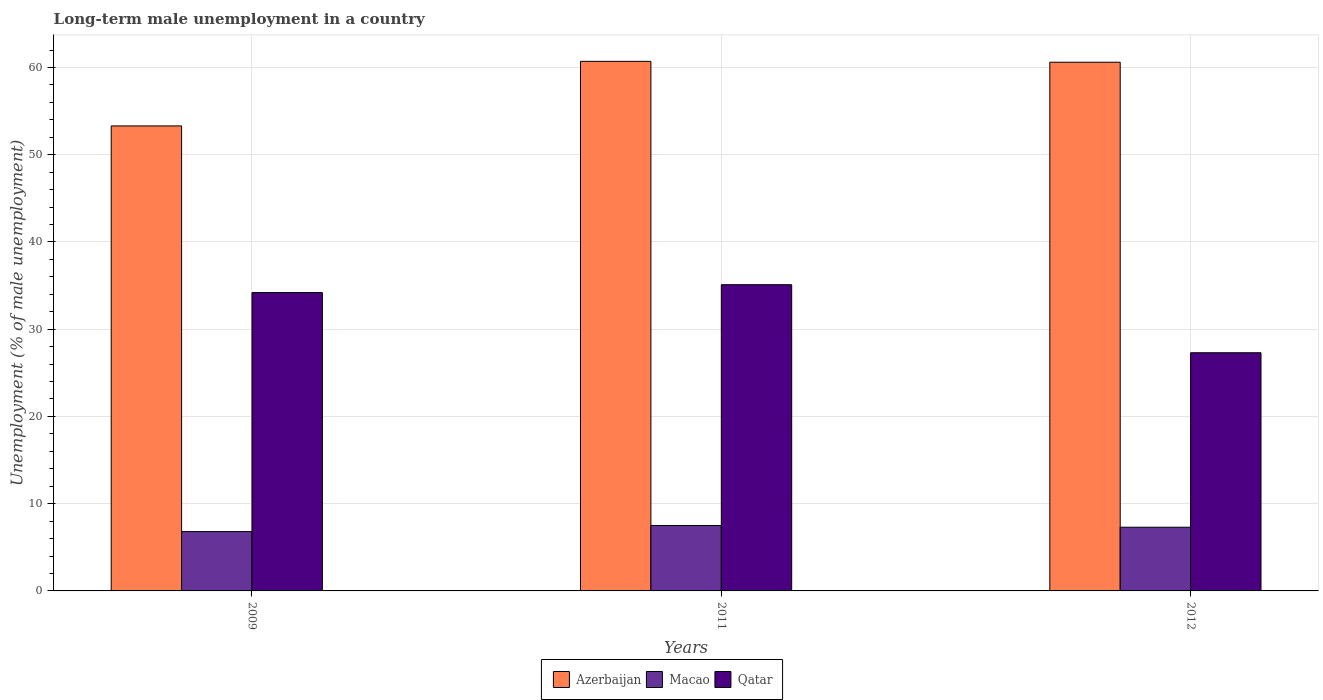How many different coloured bars are there?
Your answer should be compact. 3. How many groups of bars are there?
Give a very brief answer. 3. Are the number of bars per tick equal to the number of legend labels?
Make the answer very short. Yes. Are the number of bars on each tick of the X-axis equal?
Provide a succinct answer. Yes. What is the label of the 1st group of bars from the left?
Your answer should be compact. 2009. In how many cases, is the number of bars for a given year not equal to the number of legend labels?
Provide a short and direct response. 0. What is the percentage of long-term unemployed male population in Macao in 2009?
Provide a short and direct response. 6.8. Across all years, what is the maximum percentage of long-term unemployed male population in Azerbaijan?
Provide a short and direct response. 60.7. Across all years, what is the minimum percentage of long-term unemployed male population in Macao?
Offer a very short reply. 6.8. In which year was the percentage of long-term unemployed male population in Qatar maximum?
Offer a very short reply. 2011. In which year was the percentage of long-term unemployed male population in Azerbaijan minimum?
Ensure brevity in your answer.  2009. What is the total percentage of long-term unemployed male population in Azerbaijan in the graph?
Offer a terse response. 174.6. What is the difference between the percentage of long-term unemployed male population in Azerbaijan in 2009 and that in 2012?
Your response must be concise. -7.3. What is the difference between the percentage of long-term unemployed male population in Qatar in 2011 and the percentage of long-term unemployed male population in Macao in 2009?
Your response must be concise. 28.3. What is the average percentage of long-term unemployed male population in Qatar per year?
Offer a very short reply. 32.2. In the year 2011, what is the difference between the percentage of long-term unemployed male population in Macao and percentage of long-term unemployed male population in Qatar?
Your answer should be very brief. -27.6. What is the ratio of the percentage of long-term unemployed male population in Azerbaijan in 2009 to that in 2012?
Give a very brief answer. 0.88. Is the percentage of long-term unemployed male population in Qatar in 2009 less than that in 2011?
Offer a very short reply. Yes. Is the difference between the percentage of long-term unemployed male population in Macao in 2009 and 2012 greater than the difference between the percentage of long-term unemployed male population in Qatar in 2009 and 2012?
Provide a short and direct response. No. What is the difference between the highest and the second highest percentage of long-term unemployed male population in Azerbaijan?
Offer a very short reply. 0.1. What is the difference between the highest and the lowest percentage of long-term unemployed male population in Qatar?
Provide a short and direct response. 7.8. Is the sum of the percentage of long-term unemployed male population in Macao in 2009 and 2012 greater than the maximum percentage of long-term unemployed male population in Qatar across all years?
Your answer should be compact. No. What does the 3rd bar from the left in 2012 represents?
Your answer should be very brief. Qatar. What does the 1st bar from the right in 2011 represents?
Give a very brief answer. Qatar. Is it the case that in every year, the sum of the percentage of long-term unemployed male population in Qatar and percentage of long-term unemployed male population in Azerbaijan is greater than the percentage of long-term unemployed male population in Macao?
Offer a very short reply. Yes. How many bars are there?
Make the answer very short. 9. How many years are there in the graph?
Ensure brevity in your answer.  3. Are the values on the major ticks of Y-axis written in scientific E-notation?
Your answer should be very brief. No. How many legend labels are there?
Give a very brief answer. 3. What is the title of the graph?
Your answer should be very brief. Long-term male unemployment in a country. What is the label or title of the X-axis?
Ensure brevity in your answer.  Years. What is the label or title of the Y-axis?
Provide a succinct answer. Unemployment (% of male unemployment). What is the Unemployment (% of male unemployment) in Azerbaijan in 2009?
Offer a very short reply. 53.3. What is the Unemployment (% of male unemployment) in Macao in 2009?
Make the answer very short. 6.8. What is the Unemployment (% of male unemployment) of Qatar in 2009?
Keep it short and to the point. 34.2. What is the Unemployment (% of male unemployment) of Azerbaijan in 2011?
Your response must be concise. 60.7. What is the Unemployment (% of male unemployment) in Macao in 2011?
Offer a terse response. 7.5. What is the Unemployment (% of male unemployment) of Qatar in 2011?
Your answer should be very brief. 35.1. What is the Unemployment (% of male unemployment) in Azerbaijan in 2012?
Offer a very short reply. 60.6. What is the Unemployment (% of male unemployment) in Macao in 2012?
Offer a very short reply. 7.3. What is the Unemployment (% of male unemployment) of Qatar in 2012?
Give a very brief answer. 27.3. Across all years, what is the maximum Unemployment (% of male unemployment) of Azerbaijan?
Your response must be concise. 60.7. Across all years, what is the maximum Unemployment (% of male unemployment) in Qatar?
Your response must be concise. 35.1. Across all years, what is the minimum Unemployment (% of male unemployment) in Azerbaijan?
Provide a short and direct response. 53.3. Across all years, what is the minimum Unemployment (% of male unemployment) in Macao?
Offer a very short reply. 6.8. Across all years, what is the minimum Unemployment (% of male unemployment) of Qatar?
Offer a terse response. 27.3. What is the total Unemployment (% of male unemployment) of Azerbaijan in the graph?
Offer a terse response. 174.6. What is the total Unemployment (% of male unemployment) in Macao in the graph?
Your answer should be very brief. 21.6. What is the total Unemployment (% of male unemployment) of Qatar in the graph?
Offer a very short reply. 96.6. What is the difference between the Unemployment (% of male unemployment) of Azerbaijan in 2009 and that in 2011?
Offer a terse response. -7.4. What is the difference between the Unemployment (% of male unemployment) in Macao in 2009 and that in 2011?
Make the answer very short. -0.7. What is the difference between the Unemployment (% of male unemployment) of Qatar in 2009 and that in 2011?
Provide a succinct answer. -0.9. What is the difference between the Unemployment (% of male unemployment) in Azerbaijan in 2009 and that in 2012?
Keep it short and to the point. -7.3. What is the difference between the Unemployment (% of male unemployment) of Macao in 2009 and that in 2012?
Ensure brevity in your answer.  -0.5. What is the difference between the Unemployment (% of male unemployment) in Qatar in 2009 and that in 2012?
Give a very brief answer. 6.9. What is the difference between the Unemployment (% of male unemployment) of Azerbaijan in 2009 and the Unemployment (% of male unemployment) of Macao in 2011?
Offer a terse response. 45.8. What is the difference between the Unemployment (% of male unemployment) in Macao in 2009 and the Unemployment (% of male unemployment) in Qatar in 2011?
Give a very brief answer. -28.3. What is the difference between the Unemployment (% of male unemployment) of Azerbaijan in 2009 and the Unemployment (% of male unemployment) of Macao in 2012?
Make the answer very short. 46. What is the difference between the Unemployment (% of male unemployment) in Macao in 2009 and the Unemployment (% of male unemployment) in Qatar in 2012?
Give a very brief answer. -20.5. What is the difference between the Unemployment (% of male unemployment) in Azerbaijan in 2011 and the Unemployment (% of male unemployment) in Macao in 2012?
Ensure brevity in your answer.  53.4. What is the difference between the Unemployment (% of male unemployment) in Azerbaijan in 2011 and the Unemployment (% of male unemployment) in Qatar in 2012?
Offer a very short reply. 33.4. What is the difference between the Unemployment (% of male unemployment) of Macao in 2011 and the Unemployment (% of male unemployment) of Qatar in 2012?
Provide a short and direct response. -19.8. What is the average Unemployment (% of male unemployment) in Azerbaijan per year?
Your response must be concise. 58.2. What is the average Unemployment (% of male unemployment) in Macao per year?
Offer a terse response. 7.2. What is the average Unemployment (% of male unemployment) in Qatar per year?
Your answer should be very brief. 32.2. In the year 2009, what is the difference between the Unemployment (% of male unemployment) in Azerbaijan and Unemployment (% of male unemployment) in Macao?
Ensure brevity in your answer.  46.5. In the year 2009, what is the difference between the Unemployment (% of male unemployment) in Azerbaijan and Unemployment (% of male unemployment) in Qatar?
Your answer should be very brief. 19.1. In the year 2009, what is the difference between the Unemployment (% of male unemployment) in Macao and Unemployment (% of male unemployment) in Qatar?
Keep it short and to the point. -27.4. In the year 2011, what is the difference between the Unemployment (% of male unemployment) of Azerbaijan and Unemployment (% of male unemployment) of Macao?
Offer a very short reply. 53.2. In the year 2011, what is the difference between the Unemployment (% of male unemployment) in Azerbaijan and Unemployment (% of male unemployment) in Qatar?
Keep it short and to the point. 25.6. In the year 2011, what is the difference between the Unemployment (% of male unemployment) of Macao and Unemployment (% of male unemployment) of Qatar?
Your answer should be compact. -27.6. In the year 2012, what is the difference between the Unemployment (% of male unemployment) in Azerbaijan and Unemployment (% of male unemployment) in Macao?
Ensure brevity in your answer.  53.3. In the year 2012, what is the difference between the Unemployment (% of male unemployment) in Azerbaijan and Unemployment (% of male unemployment) in Qatar?
Ensure brevity in your answer.  33.3. What is the ratio of the Unemployment (% of male unemployment) in Azerbaijan in 2009 to that in 2011?
Give a very brief answer. 0.88. What is the ratio of the Unemployment (% of male unemployment) of Macao in 2009 to that in 2011?
Your answer should be compact. 0.91. What is the ratio of the Unemployment (% of male unemployment) in Qatar in 2009 to that in 2011?
Your answer should be very brief. 0.97. What is the ratio of the Unemployment (% of male unemployment) of Azerbaijan in 2009 to that in 2012?
Your answer should be compact. 0.88. What is the ratio of the Unemployment (% of male unemployment) in Macao in 2009 to that in 2012?
Your response must be concise. 0.93. What is the ratio of the Unemployment (% of male unemployment) of Qatar in 2009 to that in 2012?
Give a very brief answer. 1.25. What is the ratio of the Unemployment (% of male unemployment) in Azerbaijan in 2011 to that in 2012?
Provide a short and direct response. 1. What is the ratio of the Unemployment (% of male unemployment) in Macao in 2011 to that in 2012?
Ensure brevity in your answer.  1.03. What is the difference between the highest and the second highest Unemployment (% of male unemployment) of Qatar?
Offer a very short reply. 0.9. What is the difference between the highest and the lowest Unemployment (% of male unemployment) of Azerbaijan?
Provide a short and direct response. 7.4. What is the difference between the highest and the lowest Unemployment (% of male unemployment) in Macao?
Offer a very short reply. 0.7. 